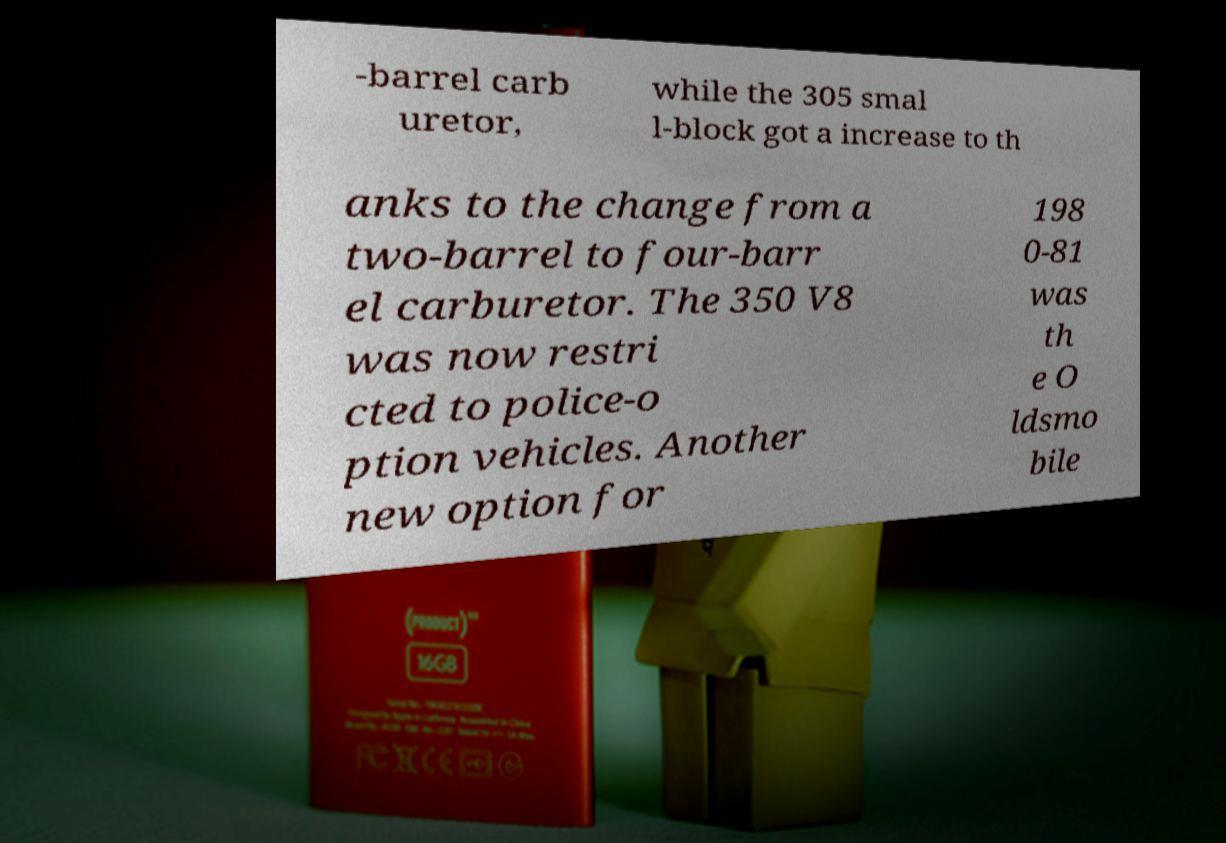Please identify and transcribe the text found in this image. -barrel carb uretor, while the 305 smal l-block got a increase to th anks to the change from a two-barrel to four-barr el carburetor. The 350 V8 was now restri cted to police-o ption vehicles. Another new option for 198 0-81 was th e O ldsmo bile 